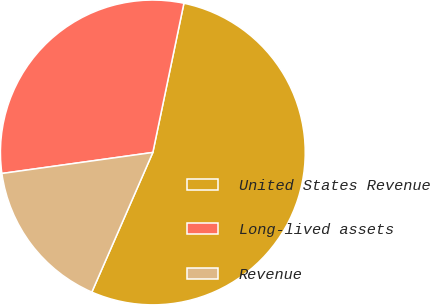<chart> <loc_0><loc_0><loc_500><loc_500><pie_chart><fcel>United States Revenue<fcel>Long-lived assets<fcel>Revenue<nl><fcel>53.28%<fcel>30.47%<fcel>16.24%<nl></chart> 